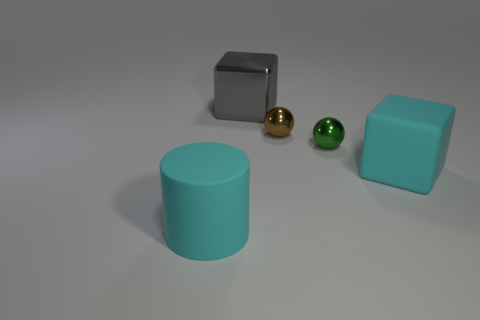Are there any other things that have the same shape as the tiny green thing? Yes, the golden sphere near the center of the image shares the same spherical shape as the tiny green sphere to its left. 